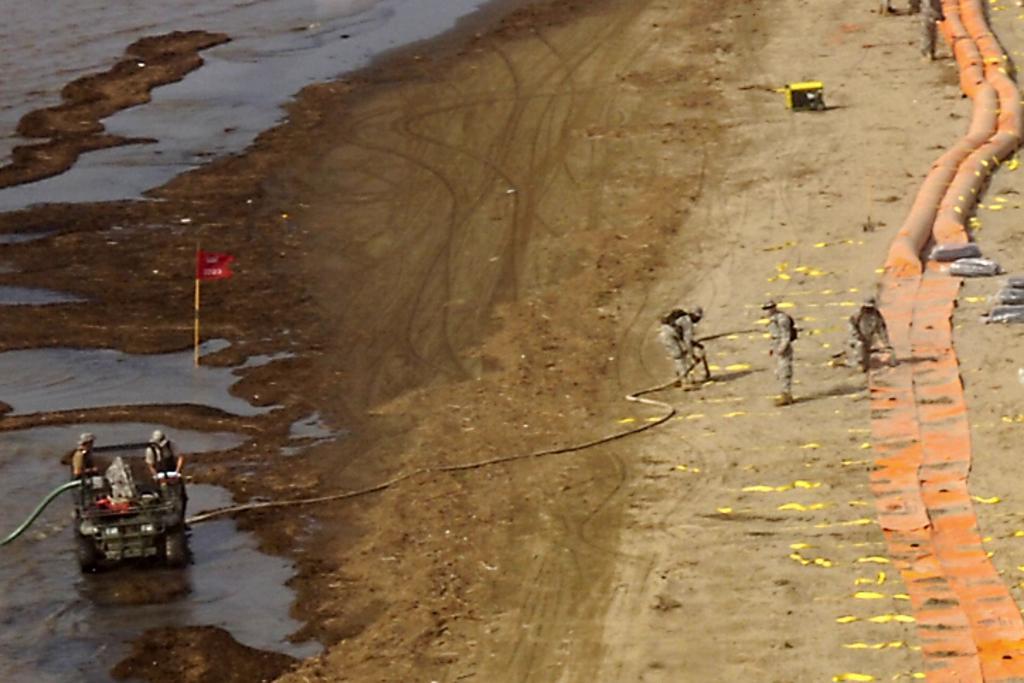Please provide a concise description of this image. In this image we can see two army people are standing on the land. Right side of the image, orange color pipes are there. Bottom of the image, one vehicle is present. Two men are there in the vehicle and one pipe is attached to the vehicle. On the land, one red color flag is there. We can see water also. 